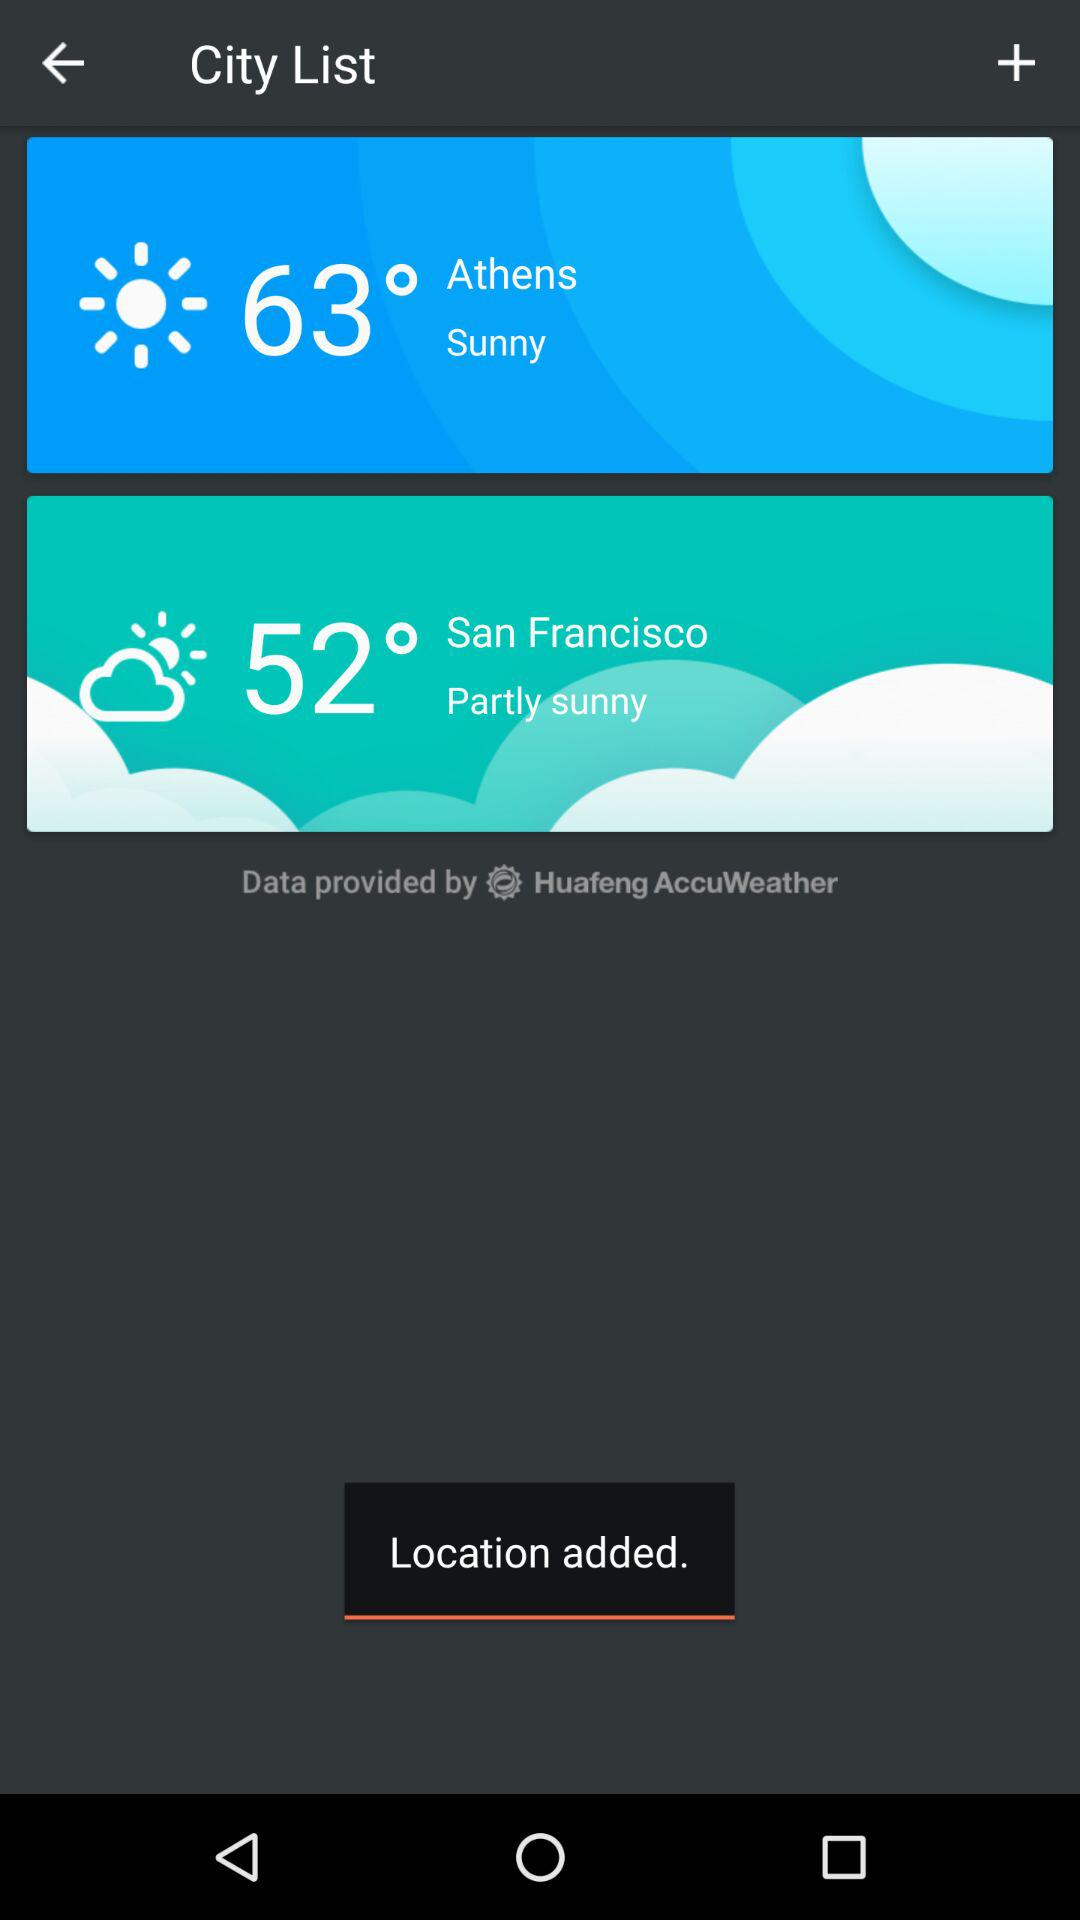What will the weather be like in Athens? The weather will be sunny. 